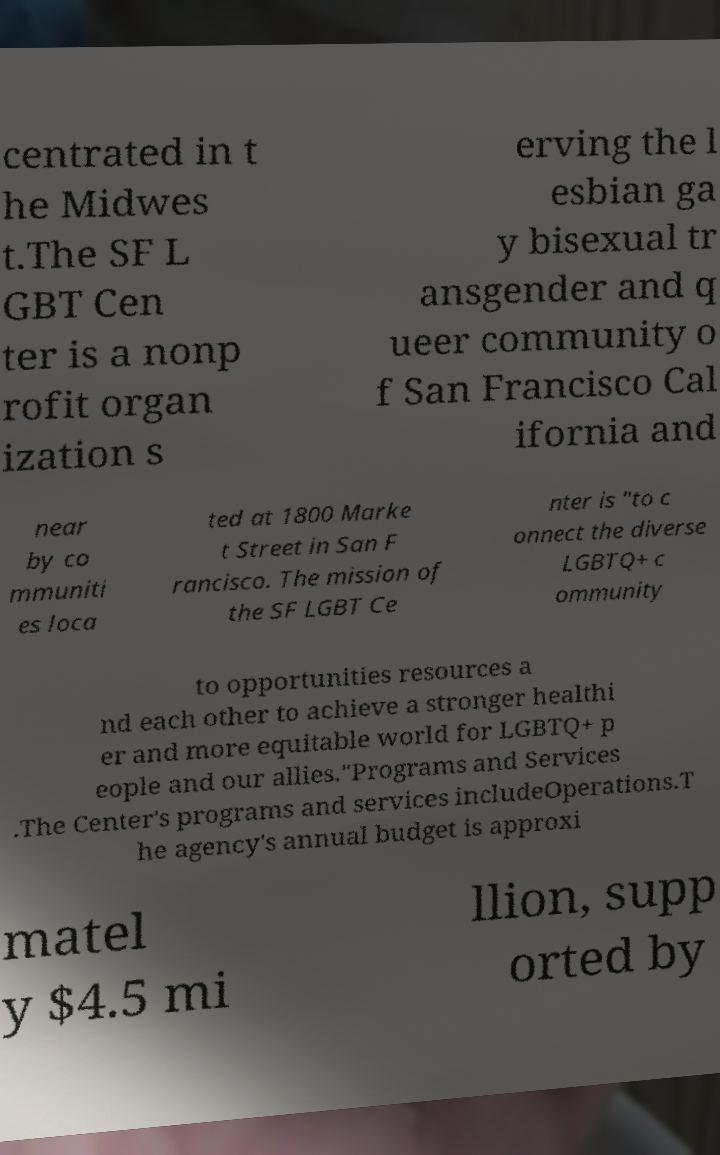Please read and relay the text visible in this image. What does it say? centrated in t he Midwes t.The SF L GBT Cen ter is a nonp rofit organ ization s erving the l esbian ga y bisexual tr ansgender and q ueer community o f San Francisco Cal ifornia and near by co mmuniti es loca ted at 1800 Marke t Street in San F rancisco. The mission of the SF LGBT Ce nter is "to c onnect the diverse LGBTQ+ c ommunity to opportunities resources a nd each other to achieve a stronger healthi er and more equitable world for LGBTQ+ p eople and our allies."Programs and Services .The Center's programs and services includeOperations.T he agency's annual budget is approxi matel y $4.5 mi llion, supp orted by 